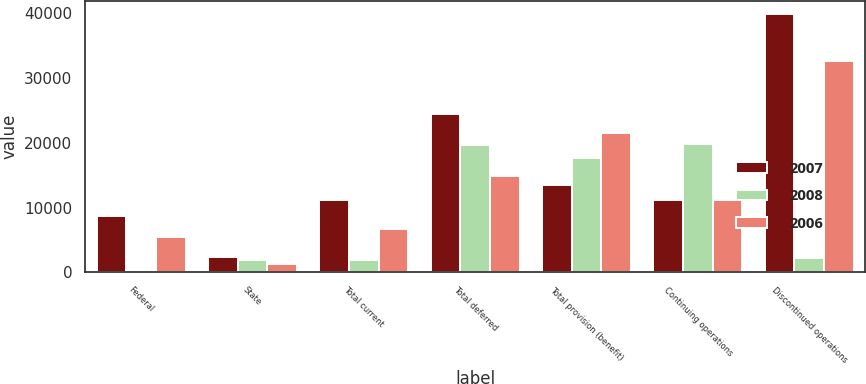<chart> <loc_0><loc_0><loc_500><loc_500><stacked_bar_chart><ecel><fcel>Federal<fcel>State<fcel>Total current<fcel>Total deferred<fcel>Total provision (benefit)<fcel>Continuing operations<fcel>Discontinued operations<nl><fcel>2007<fcel>8678<fcel>2415<fcel>11093<fcel>24501<fcel>13408<fcel>11094<fcel>39963<nl><fcel>2008<fcel>20<fcel>1938<fcel>1958<fcel>19649<fcel>17691<fcel>19840<fcel>2149<nl><fcel>2006<fcel>5380<fcel>1272<fcel>6652<fcel>14895<fcel>21547<fcel>11095<fcel>32642<nl></chart> 